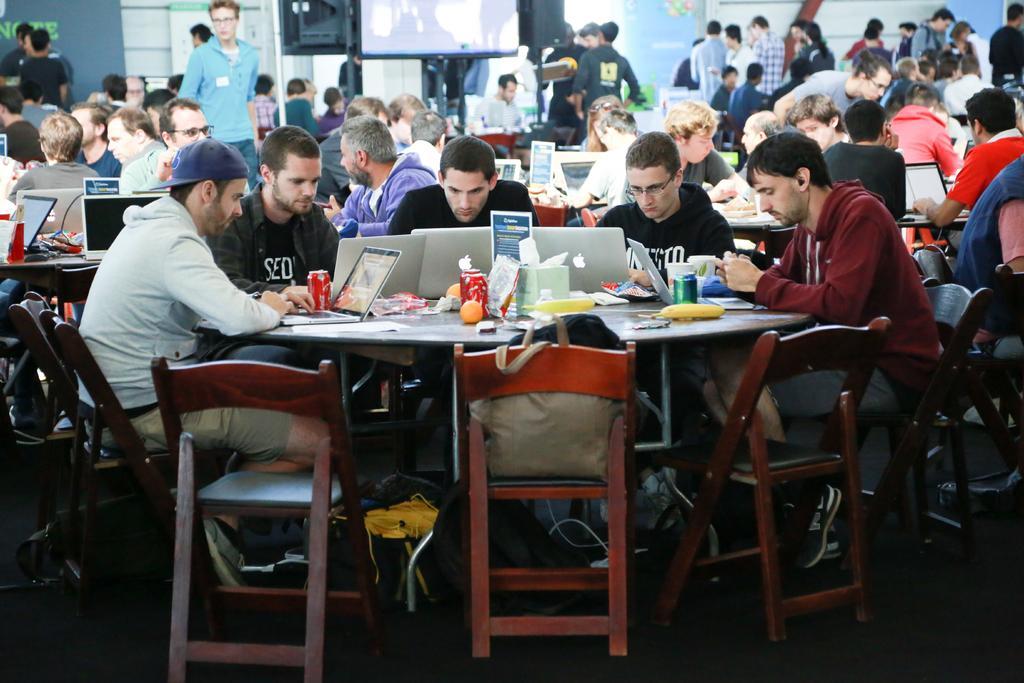Can you describe this image briefly? In this image I can see the group of people. Among them some people are sitting and some are standing. In front of them there is a laptop,on,board and some of the objects on the the table. There is also a screen in hd image. 